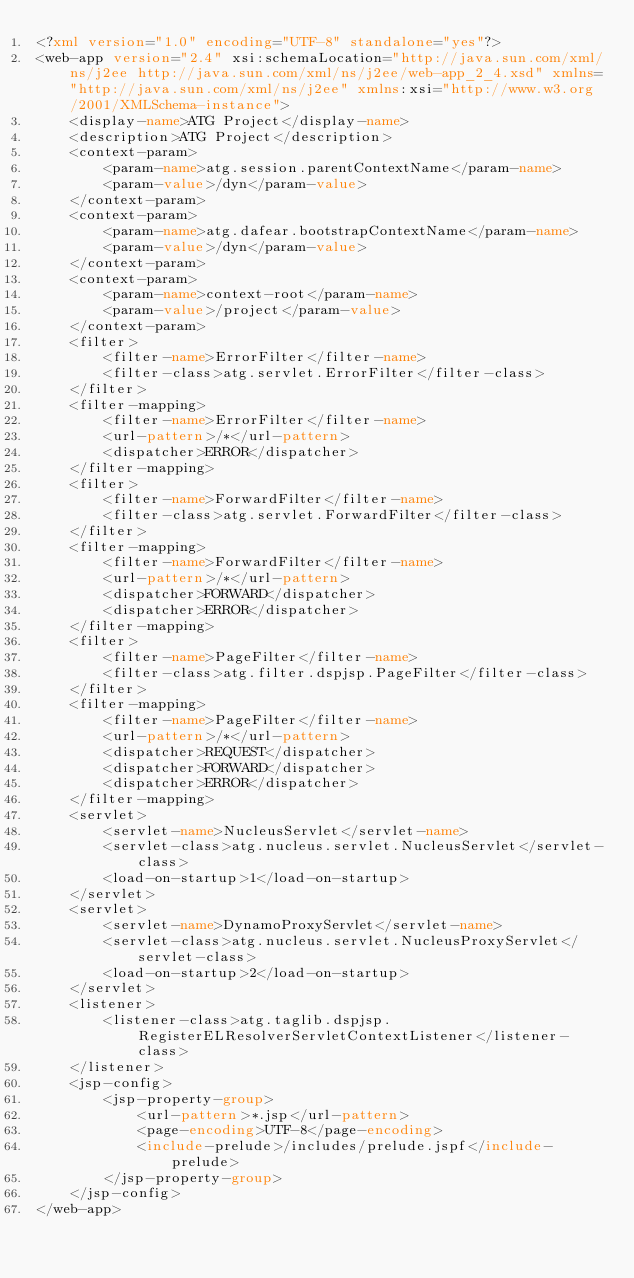<code> <loc_0><loc_0><loc_500><loc_500><_XML_><?xml version="1.0" encoding="UTF-8" standalone="yes"?>
<web-app version="2.4" xsi:schemaLocation="http://java.sun.com/xml/ns/j2ee http://java.sun.com/xml/ns/j2ee/web-app_2_4.xsd" xmlns="http://java.sun.com/xml/ns/j2ee" xmlns:xsi="http://www.w3.org/2001/XMLSchema-instance">
    <display-name>ATG Project</display-name>
    <description>ATG Project</description>
    <context-param>
        <param-name>atg.session.parentContextName</param-name>
        <param-value>/dyn</param-value>
    </context-param>
    <context-param>
        <param-name>atg.dafear.bootstrapContextName</param-name>
        <param-value>/dyn</param-value>
    </context-param>
    <context-param>
        <param-name>context-root</param-name>
        <param-value>/project</param-value>
    </context-param>
    <filter>
        <filter-name>ErrorFilter</filter-name>
        <filter-class>atg.servlet.ErrorFilter</filter-class>
    </filter>
    <filter-mapping>
        <filter-name>ErrorFilter</filter-name>
        <url-pattern>/*</url-pattern>
        <dispatcher>ERROR</dispatcher>
    </filter-mapping>
    <filter>
        <filter-name>ForwardFilter</filter-name>
        <filter-class>atg.servlet.ForwardFilter</filter-class>
    </filter>
    <filter-mapping>
        <filter-name>ForwardFilter</filter-name>
        <url-pattern>/*</url-pattern>
        <dispatcher>FORWARD</dispatcher>
        <dispatcher>ERROR</dispatcher>
    </filter-mapping>
    <filter>
        <filter-name>PageFilter</filter-name>
        <filter-class>atg.filter.dspjsp.PageFilter</filter-class>
    </filter>
    <filter-mapping>
        <filter-name>PageFilter</filter-name>
        <url-pattern>/*</url-pattern>
        <dispatcher>REQUEST</dispatcher>
        <dispatcher>FORWARD</dispatcher>
        <dispatcher>ERROR</dispatcher>
    </filter-mapping>
    <servlet>
        <servlet-name>NucleusServlet</servlet-name>
        <servlet-class>atg.nucleus.servlet.NucleusServlet</servlet-class>
        <load-on-startup>1</load-on-startup>
    </servlet>
    <servlet>
        <servlet-name>DynamoProxyServlet</servlet-name>
        <servlet-class>atg.nucleus.servlet.NucleusProxyServlet</servlet-class>
        <load-on-startup>2</load-on-startup>
    </servlet>
    <listener>
        <listener-class>atg.taglib.dspjsp.RegisterELResolverServletContextListener</listener-class>
    </listener>
    <jsp-config>
        <jsp-property-group>
            <url-pattern>*.jsp</url-pattern>
            <page-encoding>UTF-8</page-encoding>
            <include-prelude>/includes/prelude.jspf</include-prelude>
        </jsp-property-group>
    </jsp-config>
</web-app>
</code> 